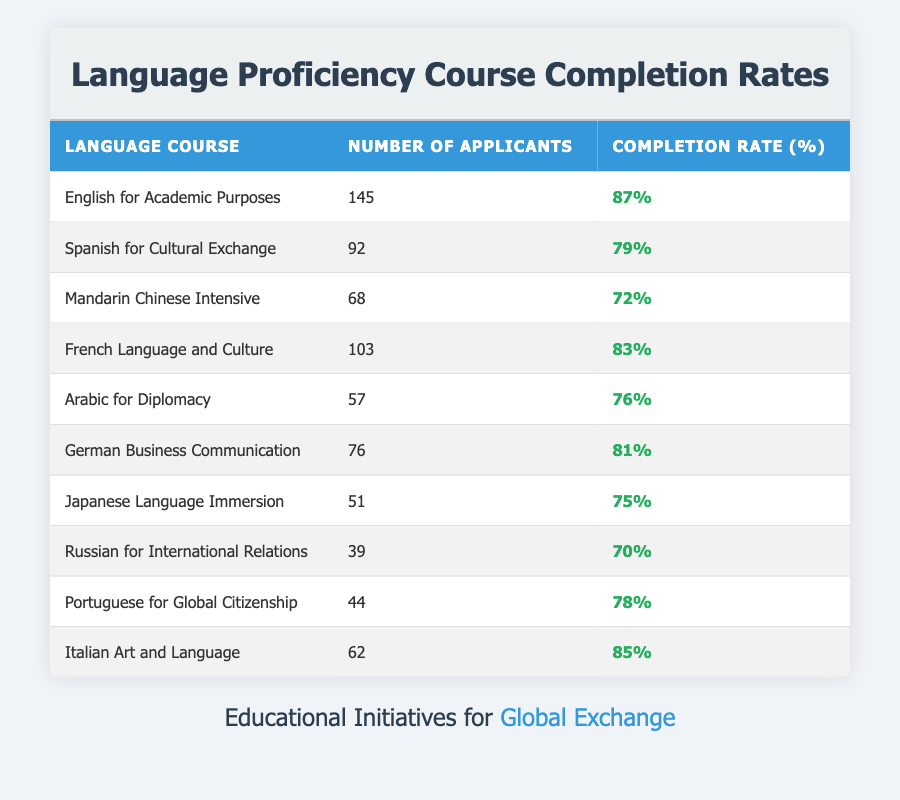What is the completion rate for the English for Academic Purposes course? The completion rate for this course is listed in the table under the "Completion Rate (%)" column for the corresponding course. It shows 87%.
Answer: 87% How many applicants enrolled in the Arabic for Diplomacy course? The number of applicants for Arabic for Diplomacy is given directly in the "Number of Applicants" column, which shows 57.
Answer: 57 Which language course has the highest completion rate? By comparing the completion rates across all courses listed in the "Completion Rate (%)" column, English for Academic Purposes has the highest rate at 87%.
Answer: English for Academic Purposes What is the average completion rate of the language courses listed? To calculate the average, sum all the completion rates: (87 + 79 + 72 + 83 + 76 + 81 + 75 + 70 + 78 + 85) = 785. Then, divide by the number of courses (10): 785 / 10 = 78.5.
Answer: 78.5 Is the completion rate for the Mandarin Chinese Intensive course above 70%? The completion rate for Mandarin Chinese Intensive is listed in the table as 72%. Since 72% is greater than 70%, this statement is true.
Answer: Yes How many language courses have a completion rate of 80% or more? By examining the "Completion Rate (%)" column, the courses with rates of 80% or more are English for Academic Purposes, French Language and Culture, German Business Communication, and Italian Art and Language. That totals four courses.
Answer: 4 What is the difference in completion rates between the highest (English for Academic Purposes) and the lowest (Russian for International Relations) courses? English for Academic Purposes has a completion rate of 87% and Russian for International Relations has a rate of 70%. The difference is calculated as 87 - 70 = 17.
Answer: 17 In total, how many applicants are there across all language courses? The total number of applicants can be calculated by summing the "Number of Applicants" column. The total is: 145 + 92 + 68 + 103 + 57 + 76 + 51 + 39 + 44 + 62 =  737.
Answer: 737 